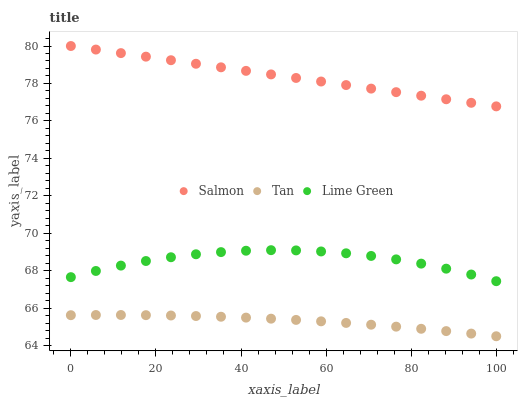Does Tan have the minimum area under the curve?
Answer yes or no. Yes. Does Salmon have the maximum area under the curve?
Answer yes or no. Yes. Does Salmon have the minimum area under the curve?
Answer yes or no. No. Does Tan have the maximum area under the curve?
Answer yes or no. No. Is Salmon the smoothest?
Answer yes or no. Yes. Is Lime Green the roughest?
Answer yes or no. Yes. Is Tan the smoothest?
Answer yes or no. No. Is Tan the roughest?
Answer yes or no. No. Does Tan have the lowest value?
Answer yes or no. Yes. Does Salmon have the lowest value?
Answer yes or no. No. Does Salmon have the highest value?
Answer yes or no. Yes. Does Tan have the highest value?
Answer yes or no. No. Is Tan less than Lime Green?
Answer yes or no. Yes. Is Salmon greater than Tan?
Answer yes or no. Yes. Does Tan intersect Lime Green?
Answer yes or no. No. 